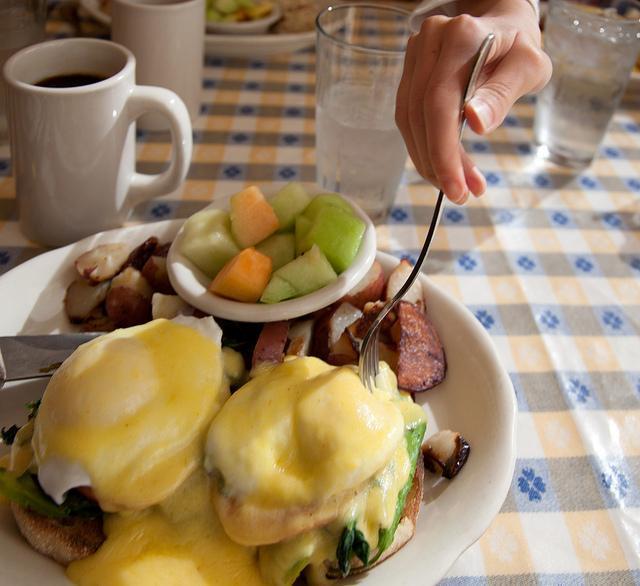How many bowls are there?
Give a very brief answer. 2. How many cups are there?
Give a very brief answer. 4. 